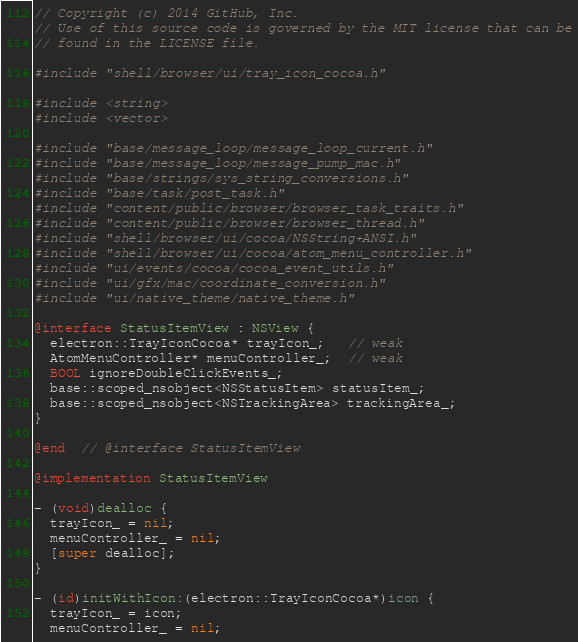<code> <loc_0><loc_0><loc_500><loc_500><_ObjectiveC_>// Copyright (c) 2014 GitHub, Inc.
// Use of this source code is governed by the MIT license that can be
// found in the LICENSE file.

#include "shell/browser/ui/tray_icon_cocoa.h"

#include <string>
#include <vector>

#include "base/message_loop/message_loop_current.h"
#include "base/message_loop/message_pump_mac.h"
#include "base/strings/sys_string_conversions.h"
#include "base/task/post_task.h"
#include "content/public/browser/browser_task_traits.h"
#include "content/public/browser/browser_thread.h"
#include "shell/browser/ui/cocoa/NSString+ANSI.h"
#include "shell/browser/ui/cocoa/atom_menu_controller.h"
#include "ui/events/cocoa/cocoa_event_utils.h"
#include "ui/gfx/mac/coordinate_conversion.h"
#include "ui/native_theme/native_theme.h"

@interface StatusItemView : NSView {
  electron::TrayIconCocoa* trayIcon_;   // weak
  AtomMenuController* menuController_;  // weak
  BOOL ignoreDoubleClickEvents_;
  base::scoped_nsobject<NSStatusItem> statusItem_;
  base::scoped_nsobject<NSTrackingArea> trackingArea_;
}

@end  // @interface StatusItemView

@implementation StatusItemView

- (void)dealloc {
  trayIcon_ = nil;
  menuController_ = nil;
  [super dealloc];
}

- (id)initWithIcon:(electron::TrayIconCocoa*)icon {
  trayIcon_ = icon;
  menuController_ = nil;</code> 